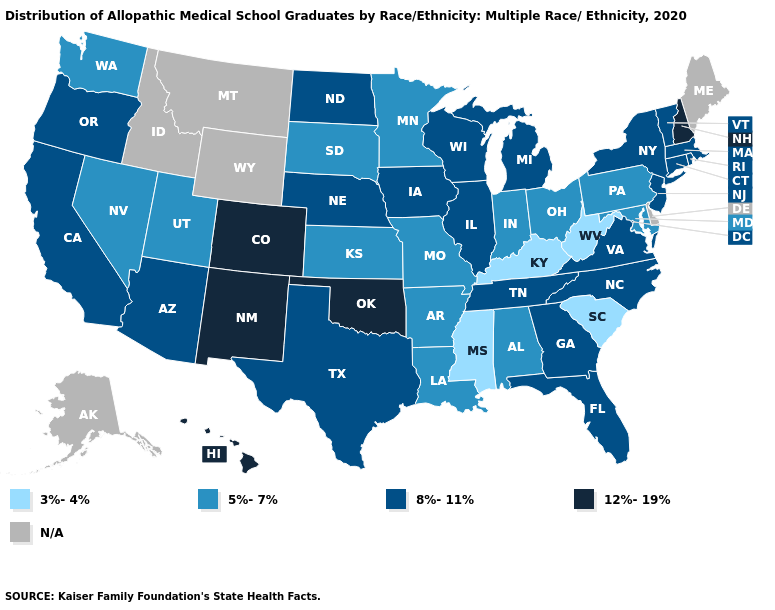Name the states that have a value in the range 5%-7%?
Quick response, please. Alabama, Arkansas, Indiana, Kansas, Louisiana, Maryland, Minnesota, Missouri, Nevada, Ohio, Pennsylvania, South Dakota, Utah, Washington. Name the states that have a value in the range N/A?
Concise answer only. Alaska, Delaware, Idaho, Maine, Montana, Wyoming. How many symbols are there in the legend?
Quick response, please. 5. Which states have the lowest value in the West?
Be succinct. Nevada, Utah, Washington. Name the states that have a value in the range N/A?
Write a very short answer. Alaska, Delaware, Idaho, Maine, Montana, Wyoming. Does West Virginia have the lowest value in the USA?
Give a very brief answer. Yes. What is the lowest value in states that border North Carolina?
Short answer required. 3%-4%. What is the value of Connecticut?
Answer briefly. 8%-11%. What is the lowest value in states that border Rhode Island?
Give a very brief answer. 8%-11%. Among the states that border Colorado , which have the lowest value?
Quick response, please. Kansas, Utah. What is the value of Montana?
Be succinct. N/A. Among the states that border North Dakota , which have the lowest value?
Short answer required. Minnesota, South Dakota. Name the states that have a value in the range 12%-19%?
Keep it brief. Colorado, Hawaii, New Hampshire, New Mexico, Oklahoma. Does the first symbol in the legend represent the smallest category?
Answer briefly. Yes. 